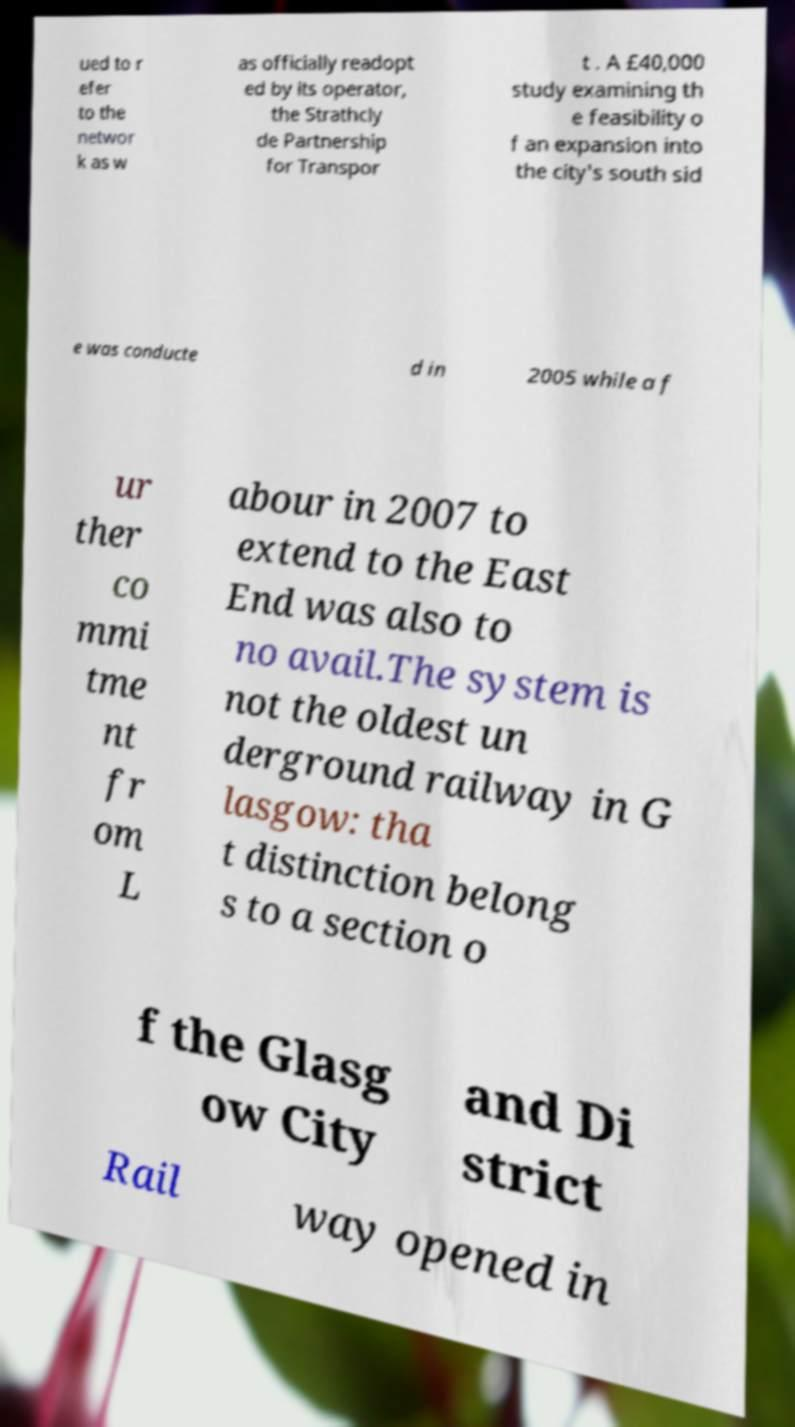What messages or text are displayed in this image? I need them in a readable, typed format. ued to r efer to the networ k as w as officially readopt ed by its operator, the Strathcly de Partnership for Transpor t . A £40,000 study examining th e feasibility o f an expansion into the city's south sid e was conducte d in 2005 while a f ur ther co mmi tme nt fr om L abour in 2007 to extend to the East End was also to no avail.The system is not the oldest un derground railway in G lasgow: tha t distinction belong s to a section o f the Glasg ow City and Di strict Rail way opened in 